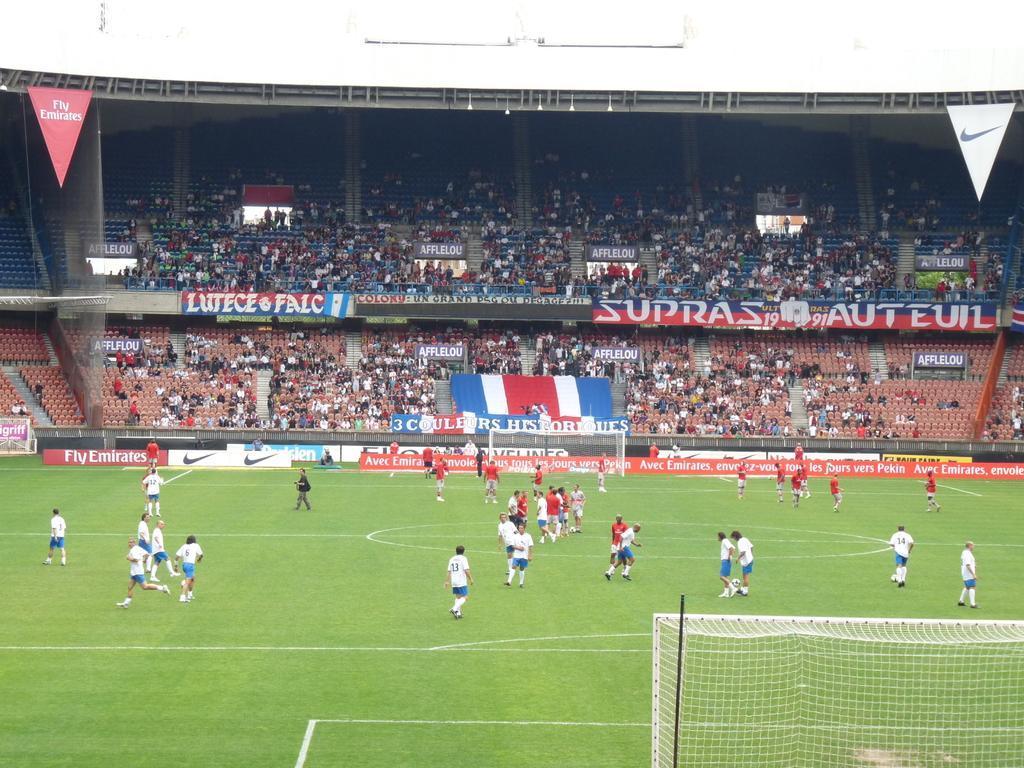Describe this image in one or two sentences. In this image we can see the players in the stadium. And we can see some people sitting. And we can see the net. And we can see the boundary wall and we can see the cloth banners. 